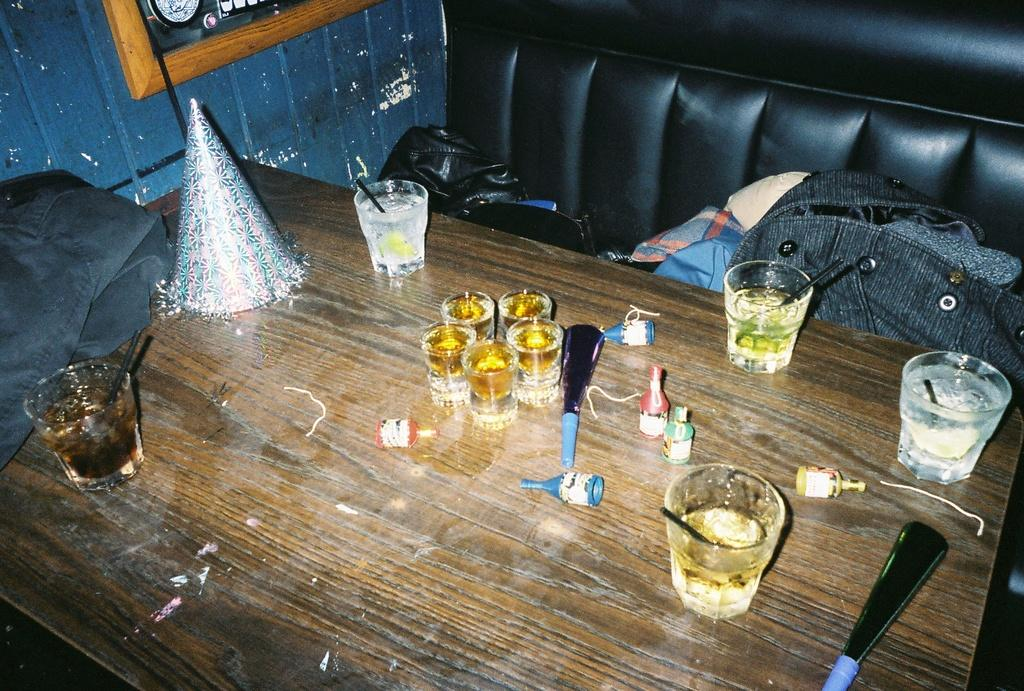What type of clothing item is on the table in the image? There is a jacket on the table in the image. What else can be seen on the table besides the jacket? There are glasses and a cap on the table in the image. Where are the clothes located in the image? The clothes are on the couch in the image. What is hanging on the wall in the image? There is a picture on the wall in the image. How many houses are visible in the image? There are no houses visible in the image. Is there a shelf present in the image? There is no shelf present in the image. 